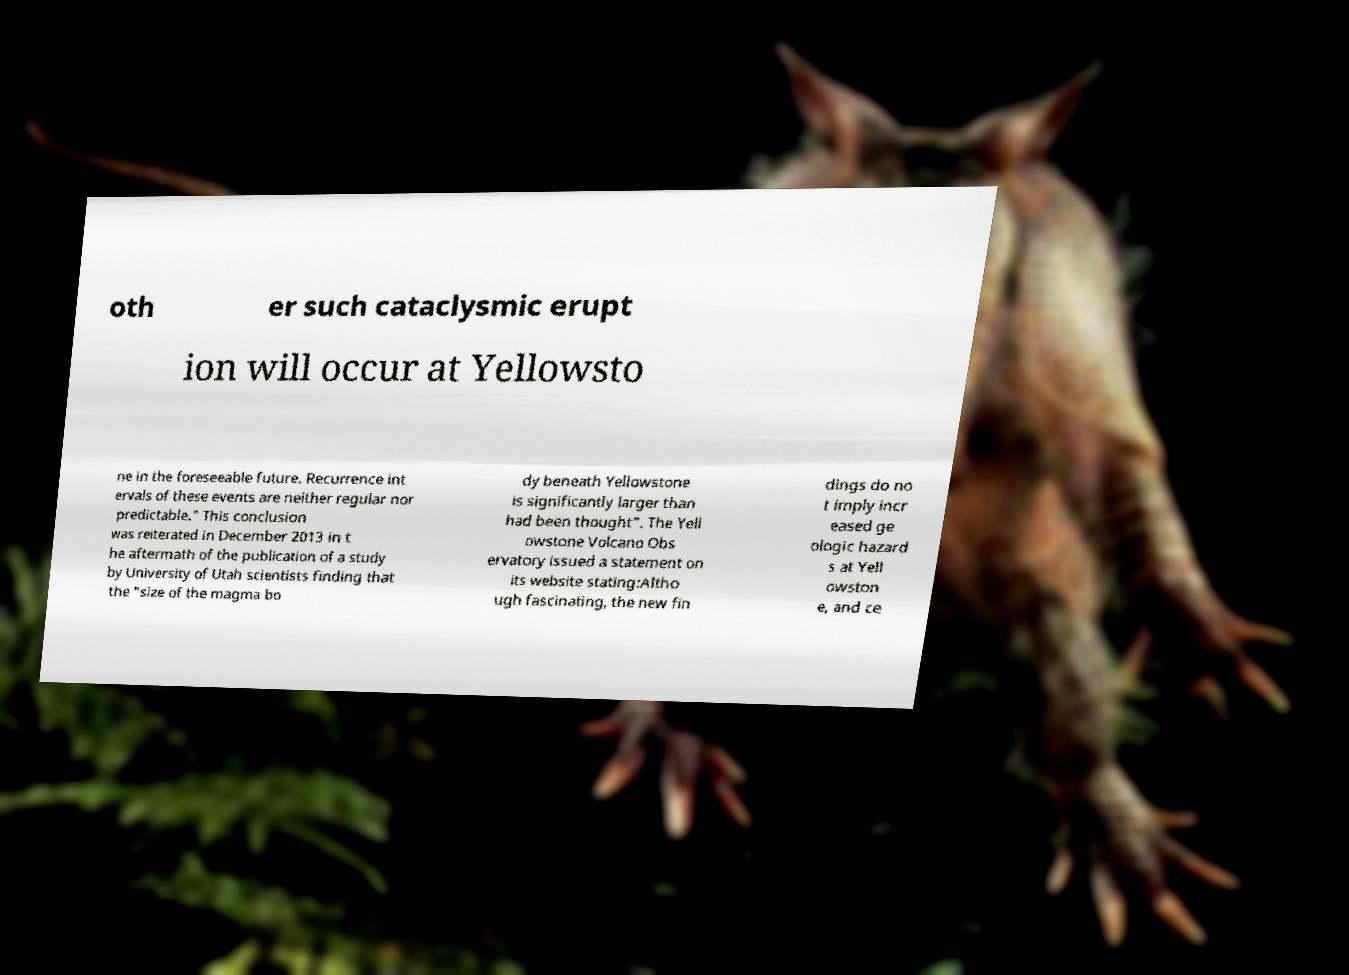There's text embedded in this image that I need extracted. Can you transcribe it verbatim? oth er such cataclysmic erupt ion will occur at Yellowsto ne in the foreseeable future. Recurrence int ervals of these events are neither regular nor predictable." This conclusion was reiterated in December 2013 in t he aftermath of the publication of a study by University of Utah scientists finding that the "size of the magma bo dy beneath Yellowstone is significantly larger than had been thought". The Yell owstone Volcano Obs ervatory issued a statement on its website stating:Altho ugh fascinating, the new fin dings do no t imply incr eased ge ologic hazard s at Yell owston e, and ce 